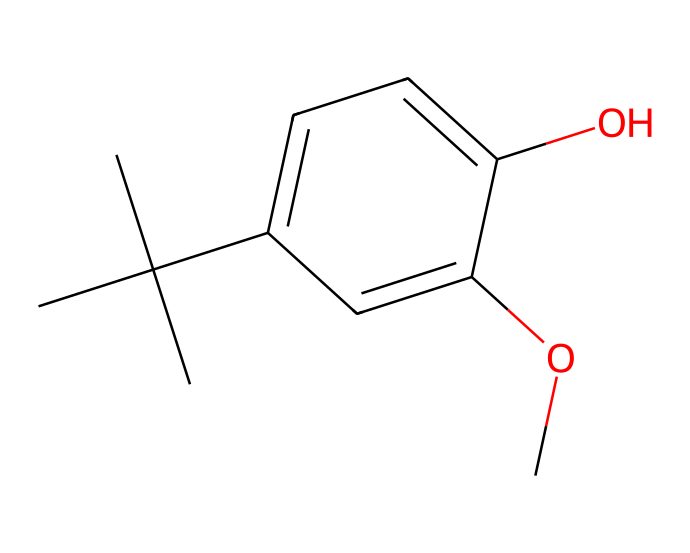What is the molecular formula of butylated hydroxyanisole? To determine the molecular formula, count the number of each type of atom present in the SMILES representation. The SMILES shows three carbon groups (from butyl), six carbons in the phenol ring, one oxygen from the methoxy group, and one from the hydroxyl group. This leads to a molecular formula of C11H14O2.
Answer: C11H14O2 How many rings are present in the structure? The SMILES format indicates a benzene ring structure due to the presence of alternating double bonds and six carbon atoms in a cyclic arrangement. There are no other cyclic structures, so there is only one ring present.
Answer: 1 What type of functional groups are present in butylated hydroxyanisole? Analyzing the SMILES, we see a hydroxyl group (-OH) and a methoxy group (-OCH3) attached to the aromatic ring. These point to the presence of phenolic and ether functional groups, respectively.
Answer: phenolic and ether Is butylated hydroxyanisole a saturated or unsaturated compound? The presence of double bonds in the benzene ring indicates that it has unsaturated carbon-carbon bonds. Hence, butylated hydroxyanisole is classified as an unsaturated compound.
Answer: unsaturated What role does butylated hydroxyanisole play in cosmetics? Butylated hydroxyanisole is used as an antioxidant to prevent oxidation of ingredients in cosmetic products, which can lead to spoilage and loss of efficacy.
Answer: antioxidant Can butylated hydroxyanisole be classified as a primary, secondary, or tertiary alcohol? By examining the structure, the hydroxyl (-OH) group is attached to a carbon that is secondary, meaning it is bonded to two other carbons in the alkyl chain. Therefore, it is classified as a secondary alcohol.
Answer: secondary 